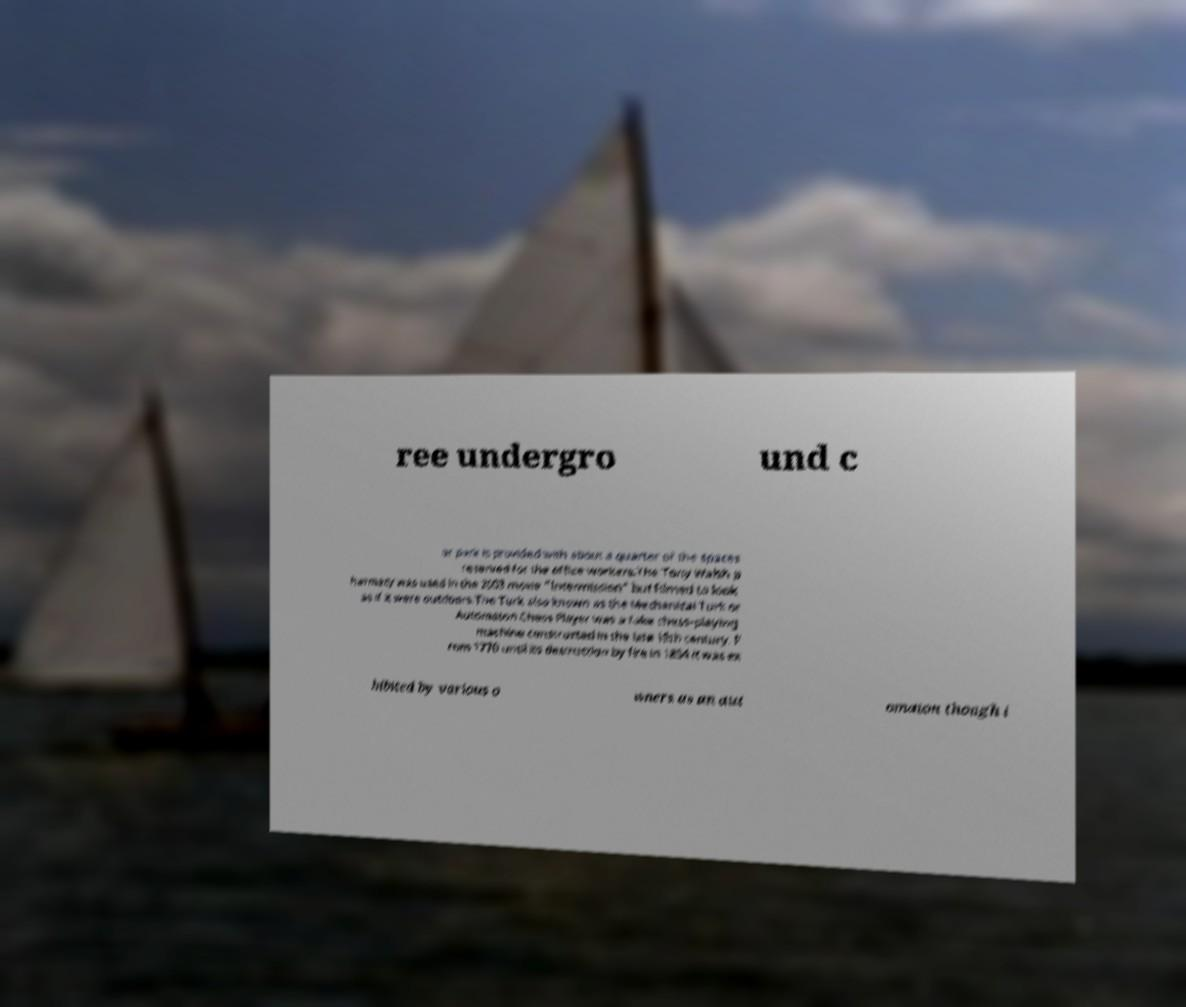Can you read and provide the text displayed in the image?This photo seems to have some interesting text. Can you extract and type it out for me? ree undergro und c ar park is provided with about a quarter of the spaces reserved for the office workers.The Tony Walsh p harmacy was used in the 2003 movie "Intermission" but filmed to look as if it were outdoors.The Turk also known as the Mechanical Turk or Automaton Chess Player was a fake chess-playing machine constructed in the late 18th century. F rom 1770 until its destruction by fire in 1854 it was ex hibited by various o wners as an aut omaton though i 